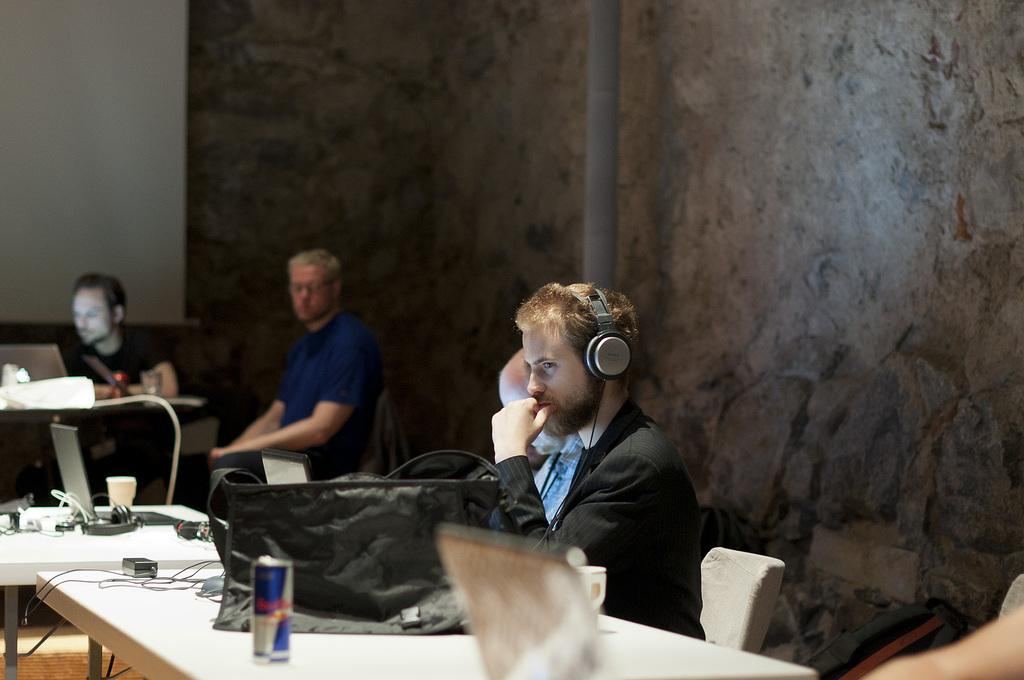How many people are sitting in the image? There are three persons sitting on chairs in the image. What is present on the table in the image? There is a bag, a tin, cables, and a laptop on the table in the image. What is the background of the image? There is a wall in the background of the image. Can you describe the fight between the two persons in the image? There is no fight depicted in the image; the three persons are sitting calmly on chairs. 